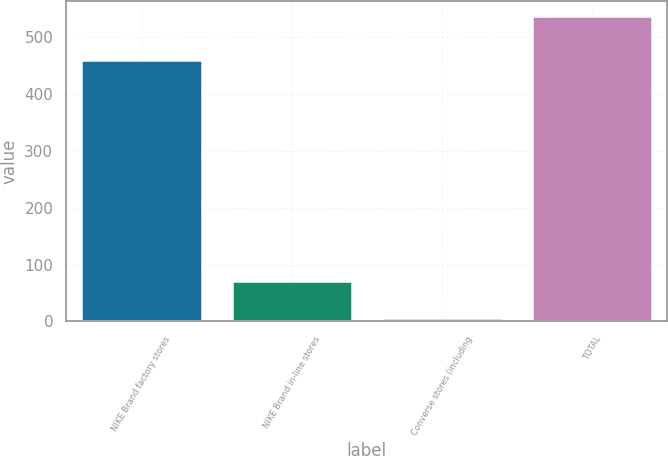Convert chart. <chart><loc_0><loc_0><loc_500><loc_500><bar_chart><fcel>NIKE Brand factory stores<fcel>NIKE Brand in-line stores<fcel>Converse stores (including<fcel>TOTAL<nl><fcel>459<fcel>71<fcel>6<fcel>536<nl></chart> 